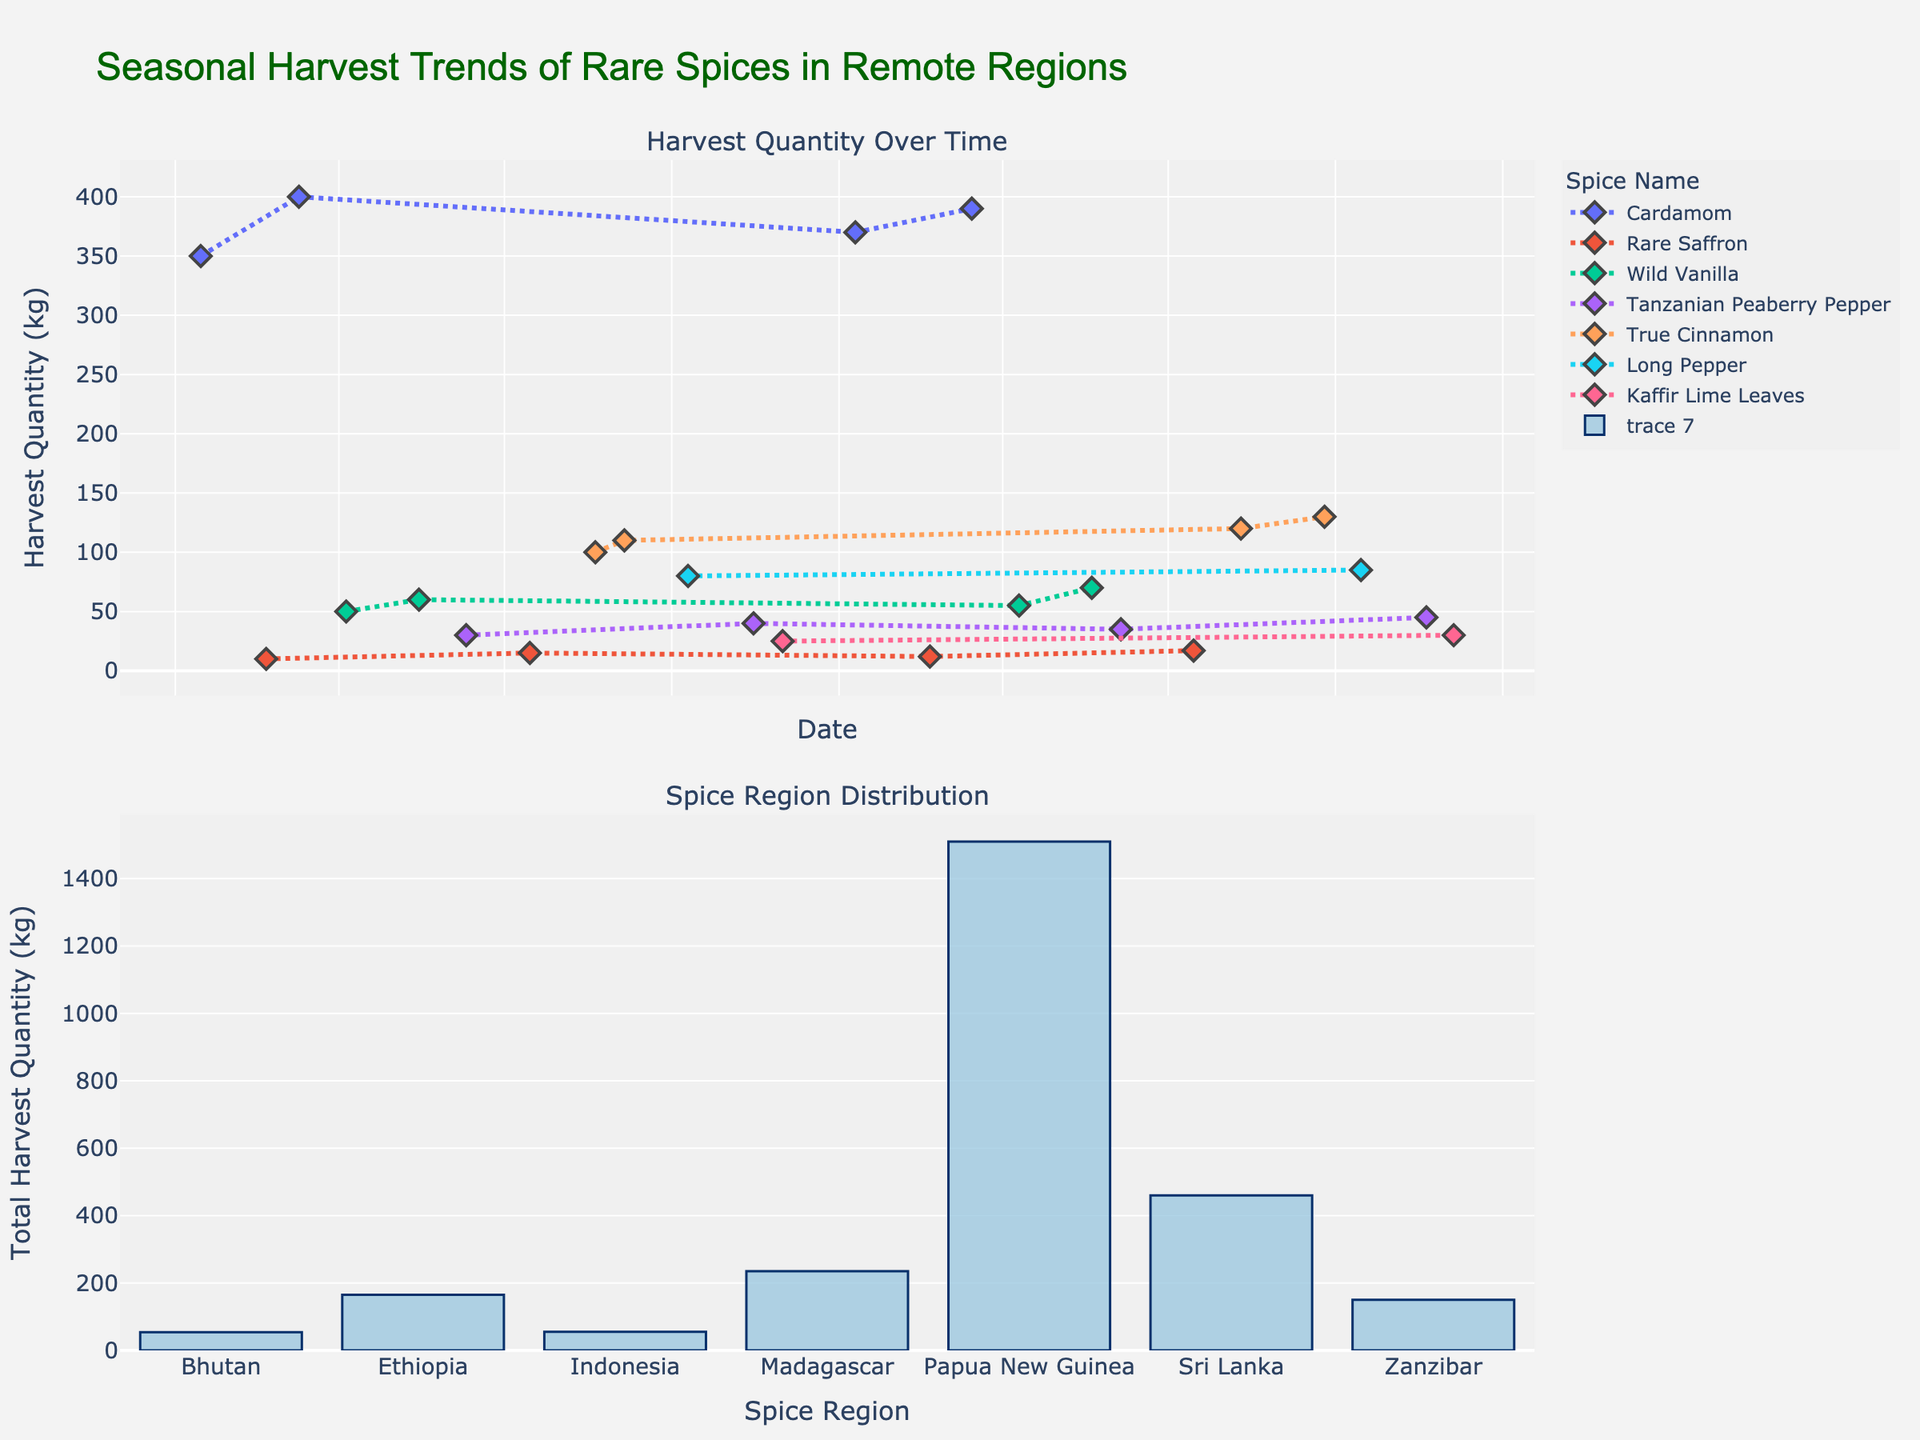What is the title of the figure? The title can be found at the top of the plot. It reads "Seasonal Harvest Trends of Rare Spices in Remote Regions".
Answer: Seasonal Harvest Trends of Rare Spices in Remote Regions How many unique spices are represented in the time series plot? By looking at the legend on the time series plot, each spice name is listed with different markers and line styles. Count the unique spice names.
Answer: 7 Which spice had the highest harvest quantity in September 2022? Look at the data points for September 2022 on the time series plot. Identify the highest harvest quantity and the corresponding spice.
Answer: True Cinnamon How does the harvest quantity of Cardamom in January 2022 compare to March 2022? Find the data points for Cardamom in January 2022 and March 2022 on the time series plot and compare their quantities.
Answer: Lower in January 2022 Which region has the highest total harvest quantity of spices? Refer to the bar chart in the second subplot where the total harvest quantity for each region is displayed. Identify the highest bar.
Answer: Papua New Guinea What is the range of harvest quantities for Wild Vanilla from April 2021 to May 2022? Locate the data points for Wild Vanilla on the time series plot between April 2021 and May 2022. Find the minimum and maximum quantities and calculate the range.
Answer: 60 (70 - 10) Which months see the harvest of Rare Saffron and how does its quantity vary? Check the time series plot for the data points related to Rare Saffron. Note down the months and respective quantities.
Answer: February, July What is the trend of Tanzanian Peaberry Pepper's harvest quantity over time? Observe the data points for Tanzanian Peaberry Pepper on the time series plot. Analyze if the quantities are increasing, decreasing, or fluctuating.
Answer: Increasing trend What is the average harvest quantity of True Cinnamon from August 2021 to September 2022? Identify the data points for True Cinnamon from August 2021 to September 2022. Sum the quantities and divide by the number of data points.
Answer: 115 How frequently is Kaffir Lime Leaves harvested? Look at the time series plot and count the number of data points corresponding to Kaffir Lime Leaves, indicating its harvest frequency.
Answer: Twice per year 